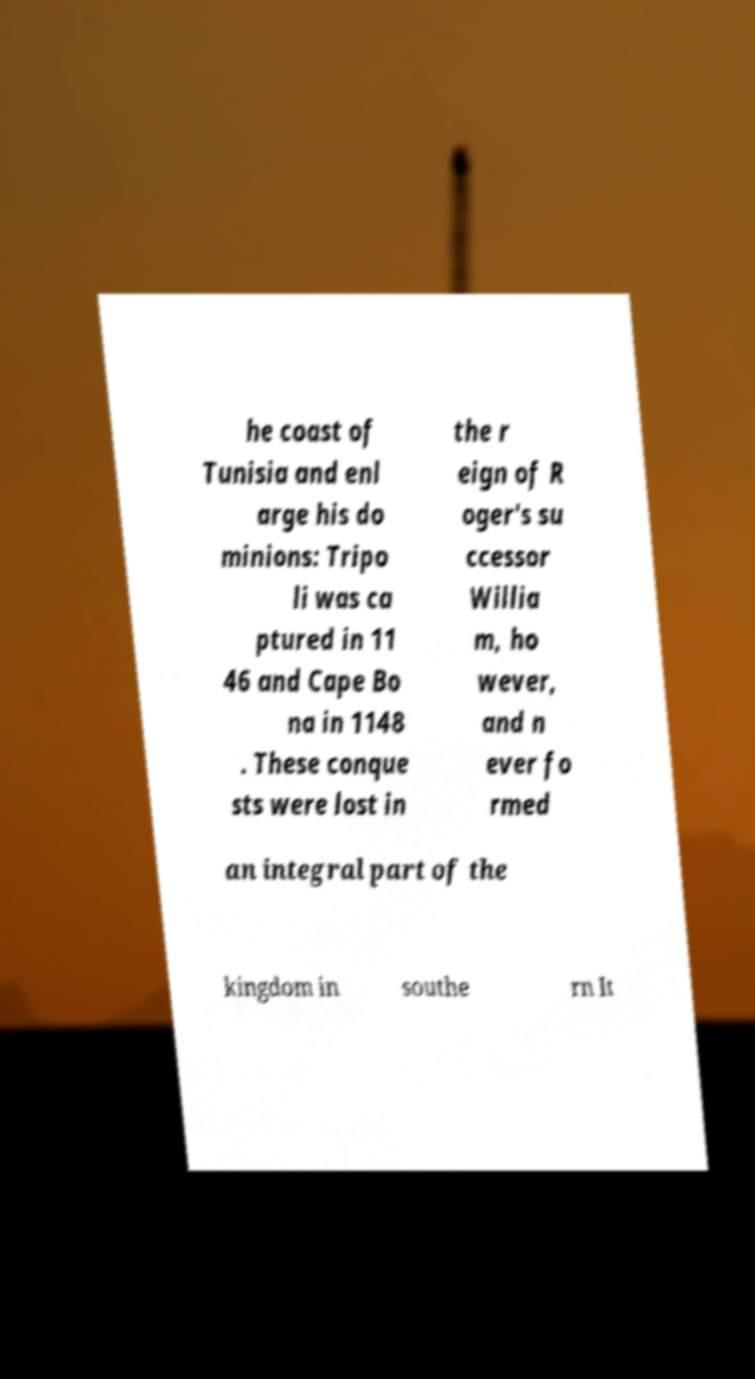Could you assist in decoding the text presented in this image and type it out clearly? he coast of Tunisia and enl arge his do minions: Tripo li was ca ptured in 11 46 and Cape Bo na in 1148 . These conque sts were lost in the r eign of R oger's su ccessor Willia m, ho wever, and n ever fo rmed an integral part of the kingdom in southe rn It 